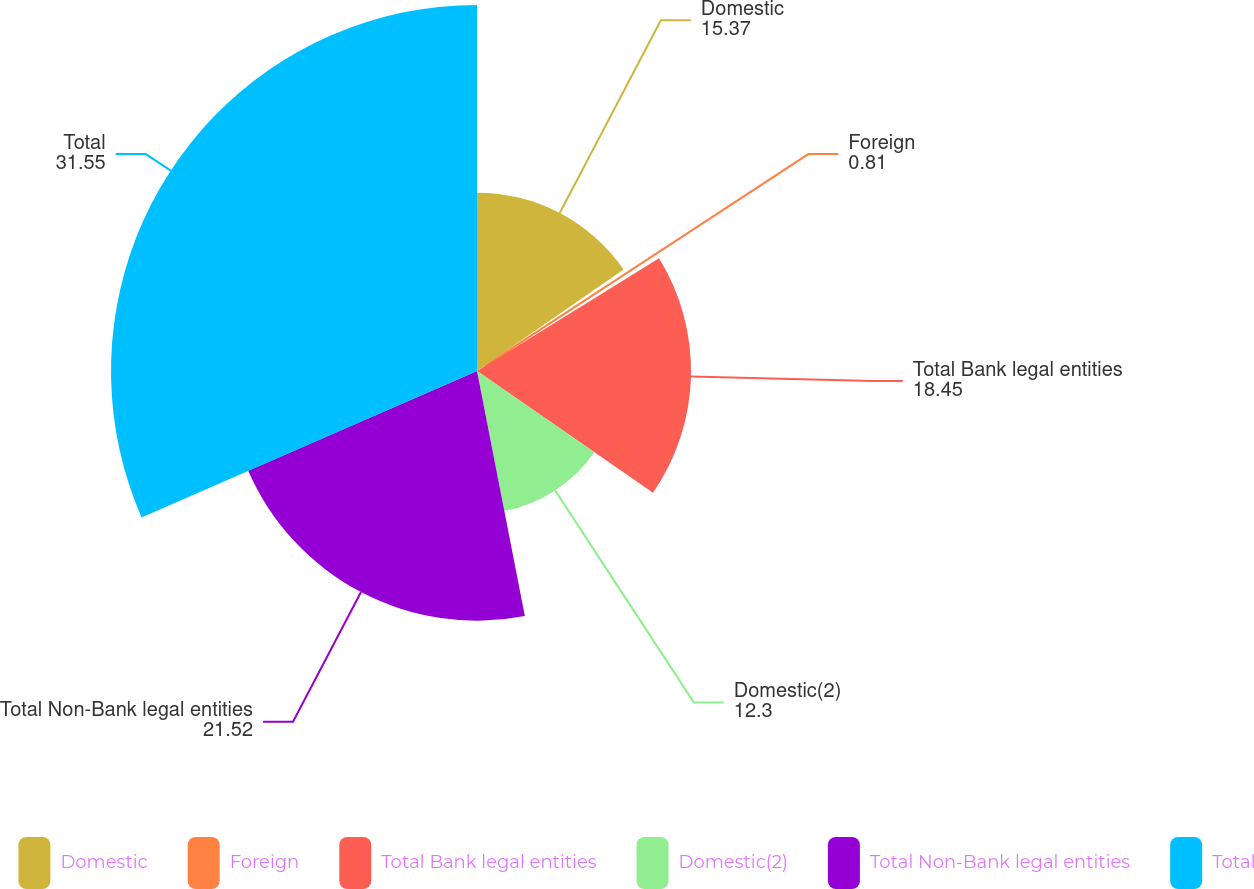<chart> <loc_0><loc_0><loc_500><loc_500><pie_chart><fcel>Domestic<fcel>Foreign<fcel>Total Bank legal entities<fcel>Domestic(2)<fcel>Total Non-Bank legal entities<fcel>Total<nl><fcel>15.37%<fcel>0.81%<fcel>18.45%<fcel>12.3%<fcel>21.52%<fcel>31.55%<nl></chart> 